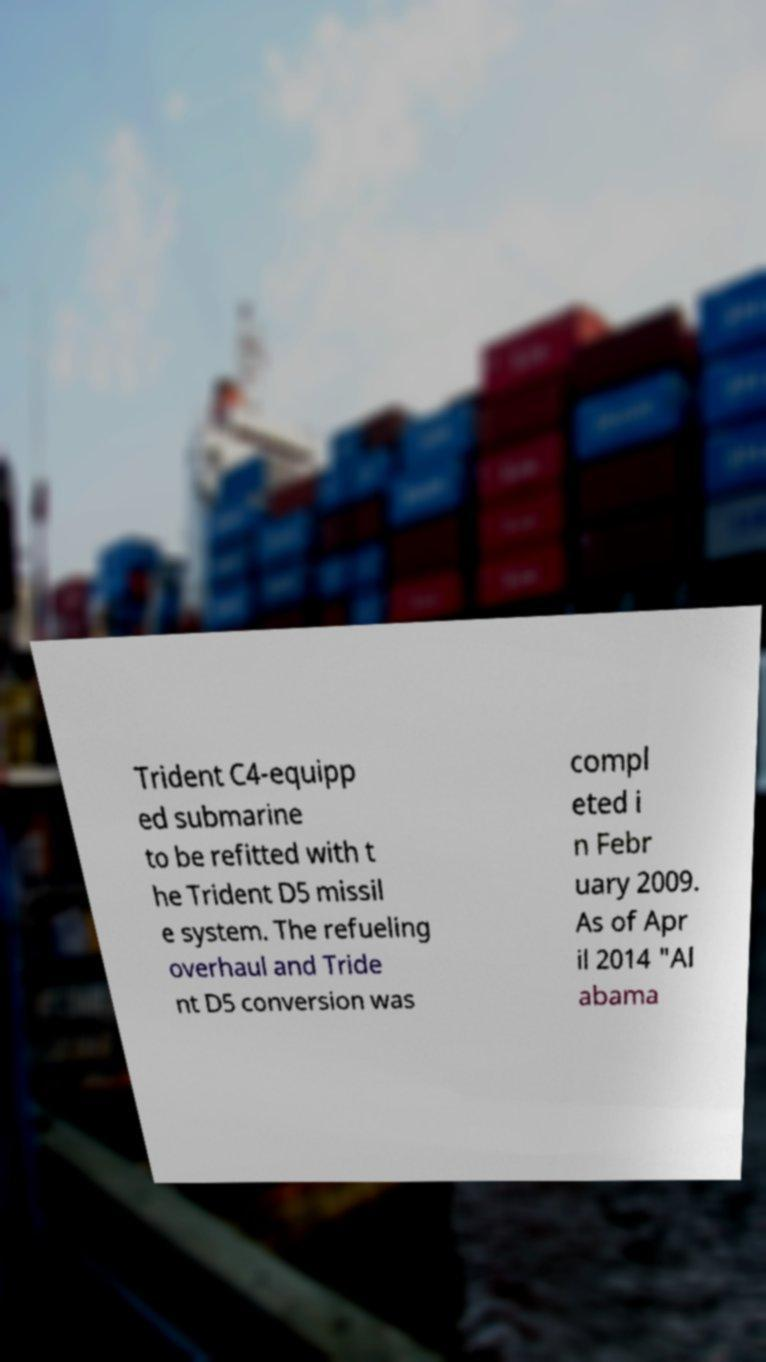Please read and relay the text visible in this image. What does it say? Trident C4-equipp ed submarine to be refitted with t he Trident D5 missil e system. The refueling overhaul and Tride nt D5 conversion was compl eted i n Febr uary 2009. As of Apr il 2014 "Al abama 